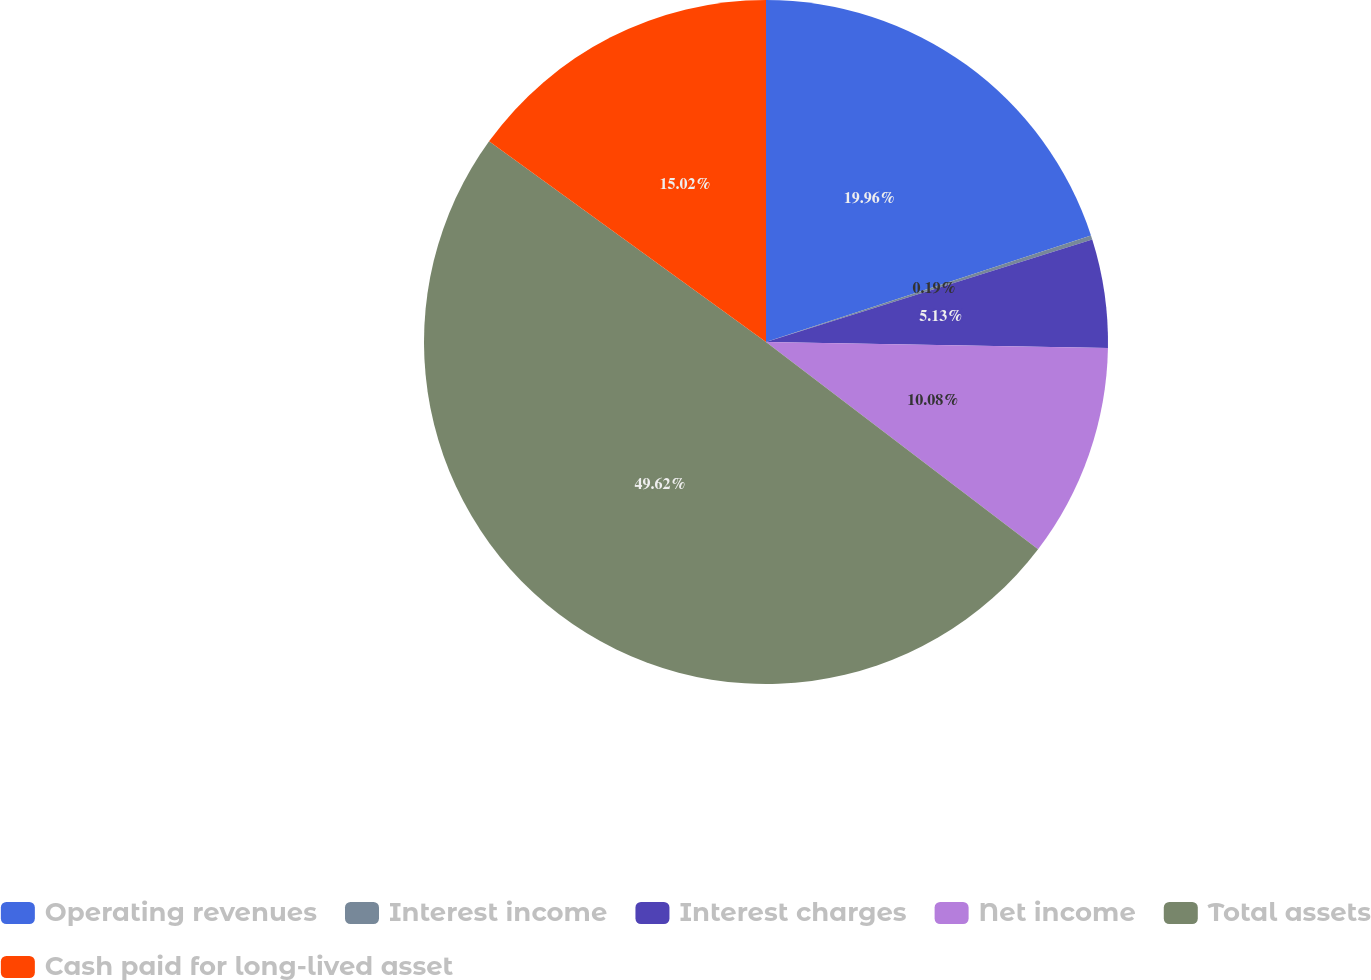Convert chart. <chart><loc_0><loc_0><loc_500><loc_500><pie_chart><fcel>Operating revenues<fcel>Interest income<fcel>Interest charges<fcel>Net income<fcel>Total assets<fcel>Cash paid for long-lived asset<nl><fcel>19.96%<fcel>0.19%<fcel>5.13%<fcel>10.08%<fcel>49.62%<fcel>15.02%<nl></chart> 